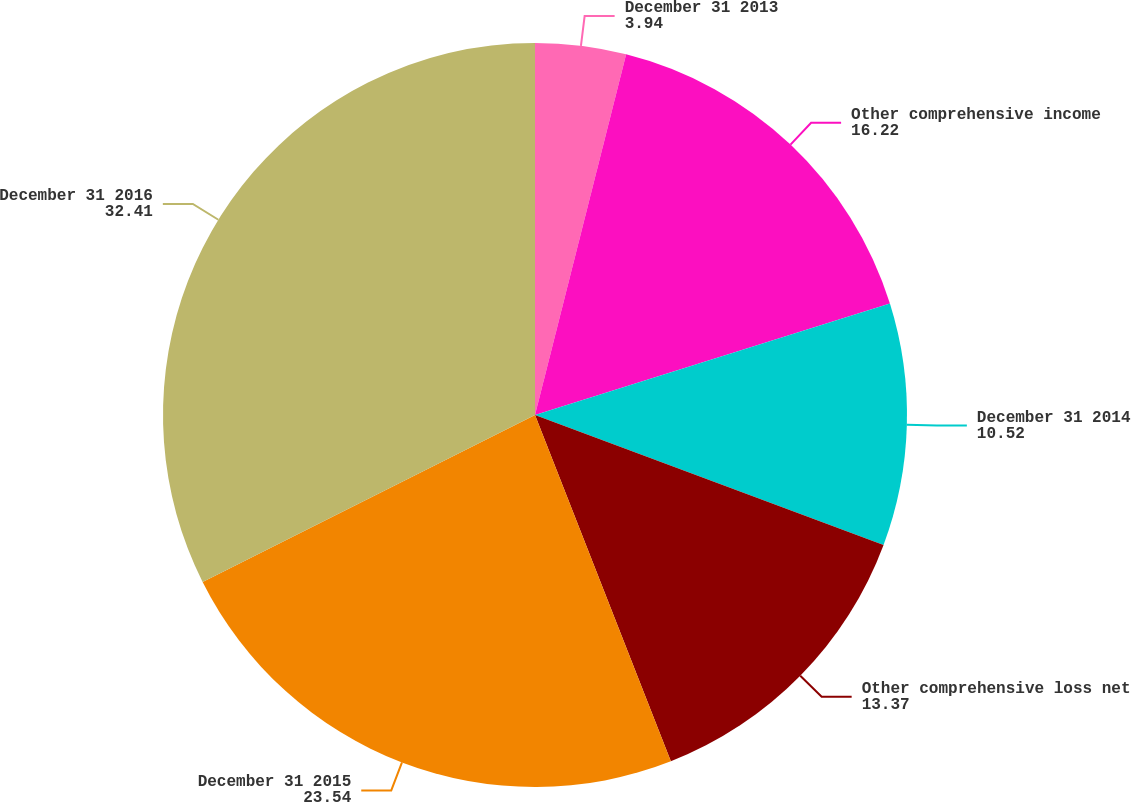Convert chart. <chart><loc_0><loc_0><loc_500><loc_500><pie_chart><fcel>December 31 2013<fcel>Other comprehensive income<fcel>December 31 2014<fcel>Other comprehensive loss net<fcel>December 31 2015<fcel>December 31 2016<nl><fcel>3.94%<fcel>16.22%<fcel>10.52%<fcel>13.37%<fcel>23.54%<fcel>32.41%<nl></chart> 